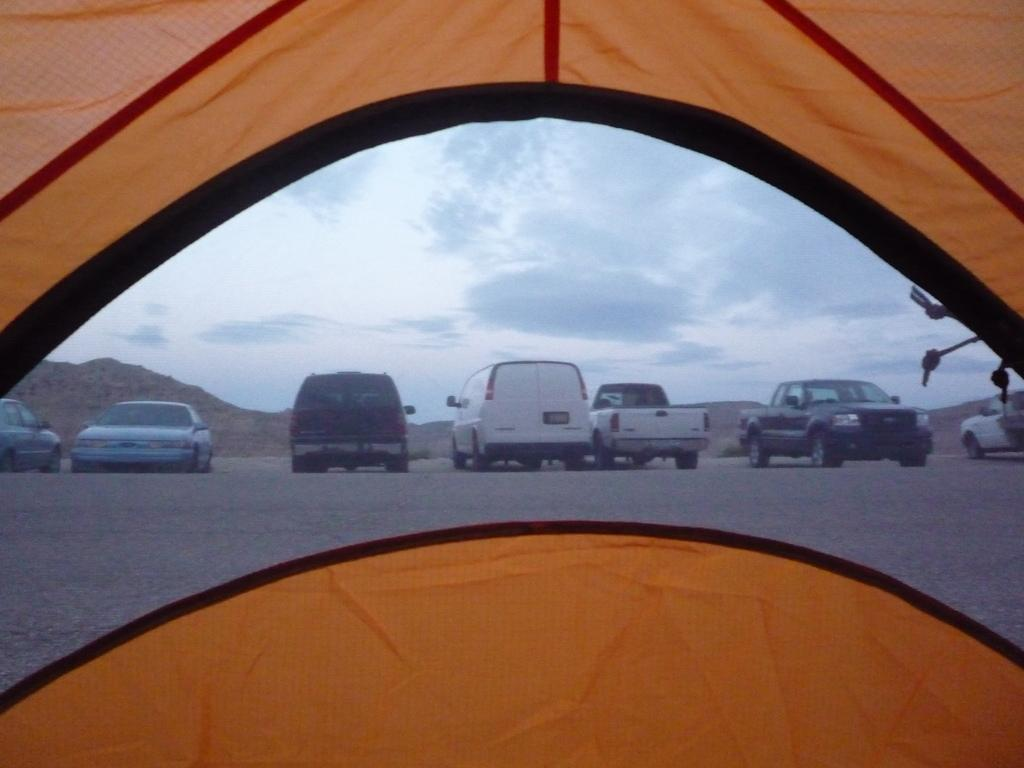What structure can be seen in the image? There is a tent in the image. What can be seen in the background of the image? There are cars, hills, and clouds visible in the background of the image. What type of yarn is being used to create the tent in the image? There is no yarn present in the image; the tent is a solid structure. 